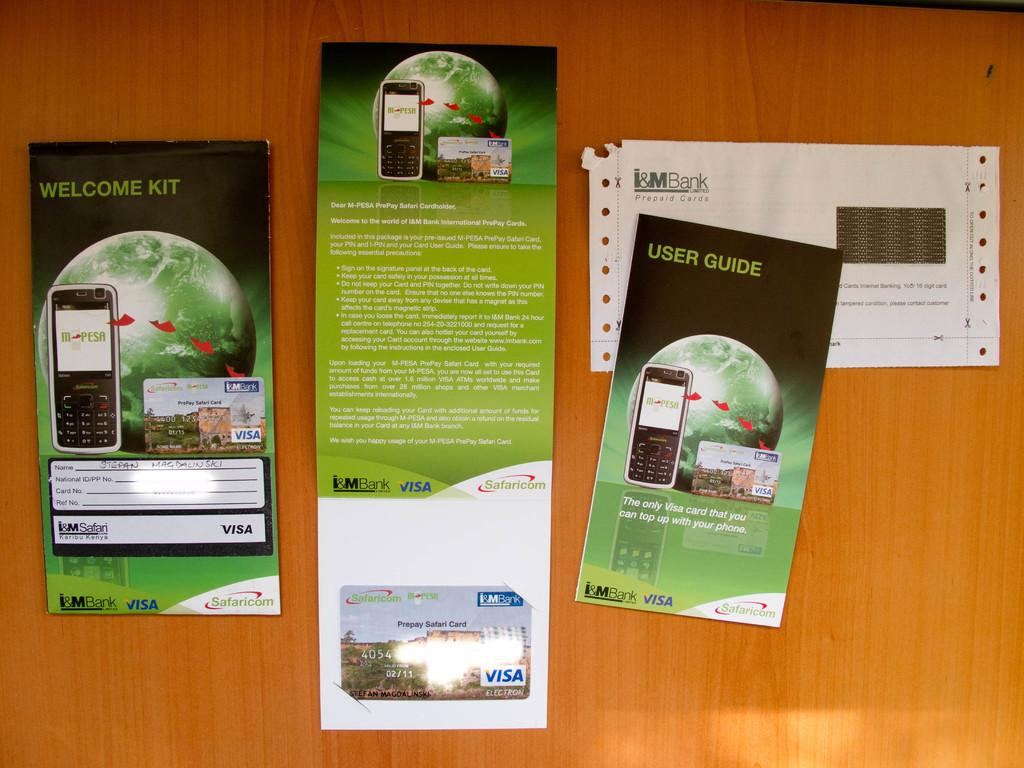<image>
Present a compact description of the photo's key features. User guide and welcome kit for a visa card 